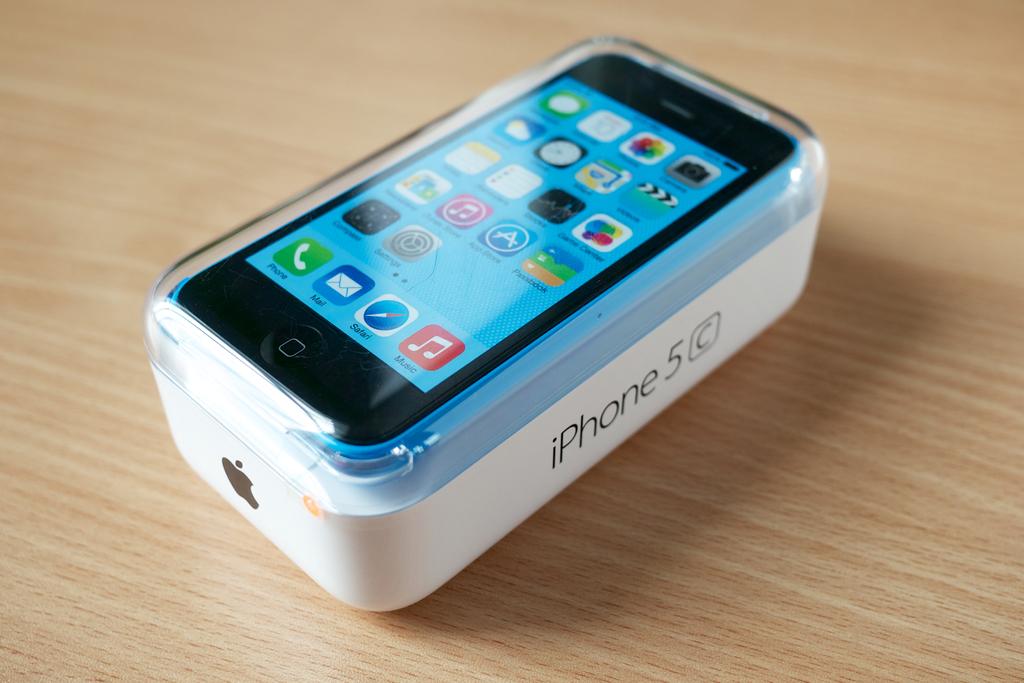What series is this iphone?
Provide a short and direct response. Iphone 5c. What is the button on the bottom right of the screen for?
Provide a succinct answer. Music. 